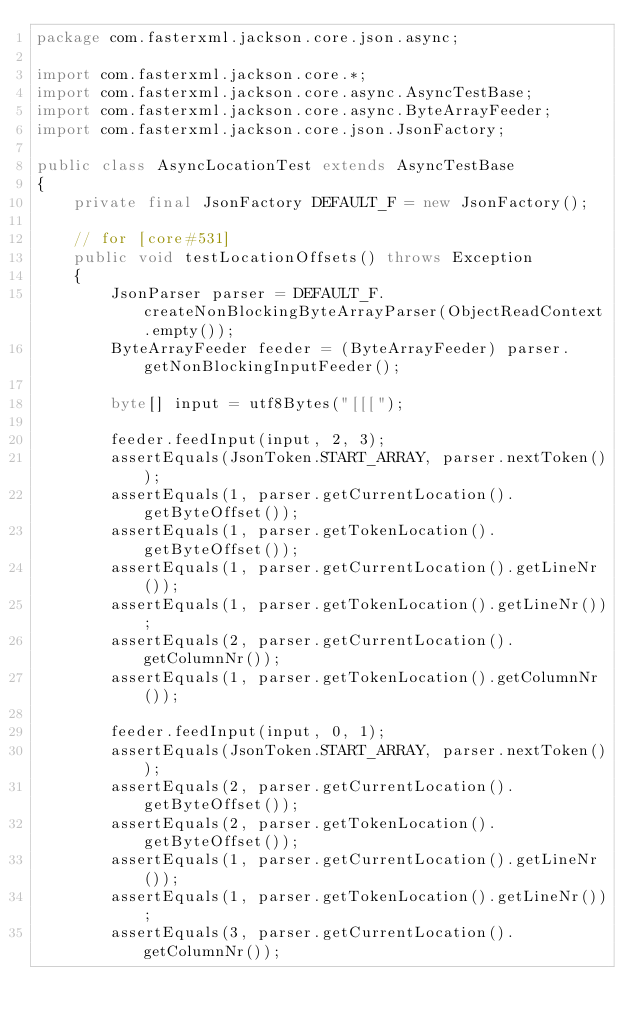<code> <loc_0><loc_0><loc_500><loc_500><_Java_>package com.fasterxml.jackson.core.json.async;

import com.fasterxml.jackson.core.*;
import com.fasterxml.jackson.core.async.AsyncTestBase;
import com.fasterxml.jackson.core.async.ByteArrayFeeder;
import com.fasterxml.jackson.core.json.JsonFactory;

public class AsyncLocationTest extends AsyncTestBase
{
    private final JsonFactory DEFAULT_F = new JsonFactory();

    // for [core#531]
    public void testLocationOffsets() throws Exception
    {
        JsonParser parser = DEFAULT_F.createNonBlockingByteArrayParser(ObjectReadContext.empty());
        ByteArrayFeeder feeder = (ByteArrayFeeder) parser.getNonBlockingInputFeeder();

        byte[] input = utf8Bytes("[[[");

        feeder.feedInput(input, 2, 3);
        assertEquals(JsonToken.START_ARRAY, parser.nextToken());
        assertEquals(1, parser.getCurrentLocation().getByteOffset());
        assertEquals(1, parser.getTokenLocation().getByteOffset());
        assertEquals(1, parser.getCurrentLocation().getLineNr());
        assertEquals(1, parser.getTokenLocation().getLineNr());
        assertEquals(2, parser.getCurrentLocation().getColumnNr());
        assertEquals(1, parser.getTokenLocation().getColumnNr());

        feeder.feedInput(input, 0, 1);
        assertEquals(JsonToken.START_ARRAY, parser.nextToken());
        assertEquals(2, parser.getCurrentLocation().getByteOffset());
        assertEquals(2, parser.getTokenLocation().getByteOffset());
        assertEquals(1, parser.getCurrentLocation().getLineNr());
        assertEquals(1, parser.getTokenLocation().getLineNr());
        assertEquals(3, parser.getCurrentLocation().getColumnNr());</code> 